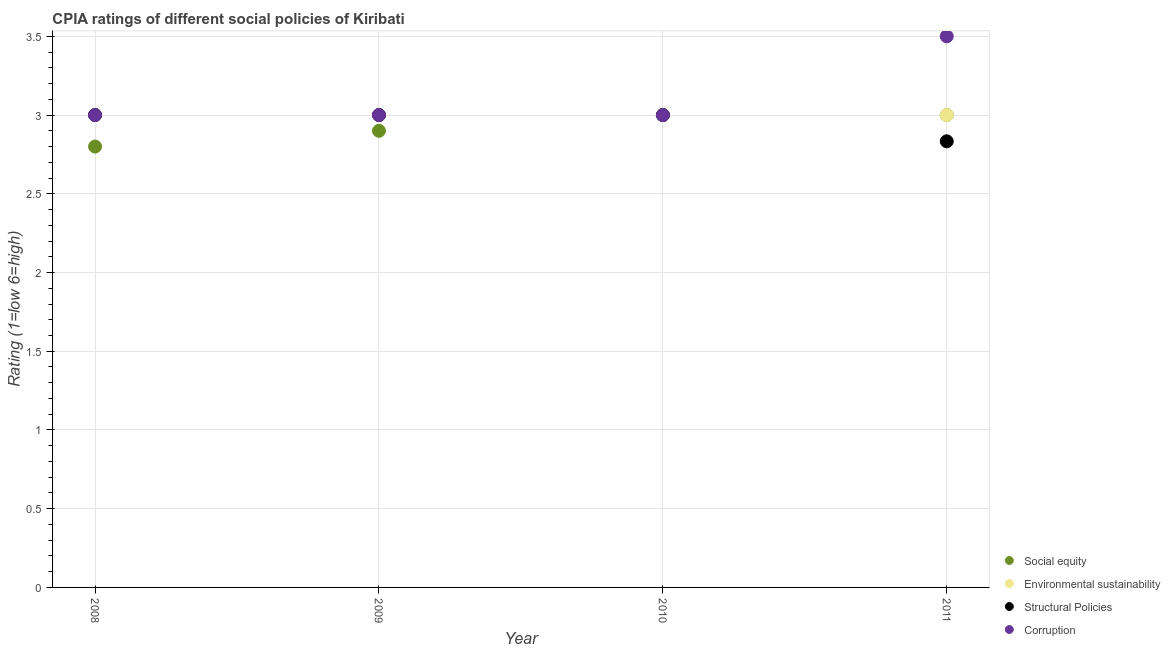Is the number of dotlines equal to the number of legend labels?
Ensure brevity in your answer.  Yes. What is the cpia rating of environmental sustainability in 2009?
Provide a short and direct response. 3. Across all years, what is the maximum cpia rating of corruption?
Your response must be concise. 3.5. Across all years, what is the minimum cpia rating of environmental sustainability?
Provide a succinct answer. 3. What is the total cpia rating of environmental sustainability in the graph?
Make the answer very short. 12. What is the difference between the cpia rating of structural policies in 2009 and the cpia rating of corruption in 2008?
Your answer should be compact. 0. What is the average cpia rating of structural policies per year?
Offer a very short reply. 2.96. Is the difference between the cpia rating of environmental sustainability in 2008 and 2011 greater than the difference between the cpia rating of social equity in 2008 and 2011?
Offer a very short reply. Yes. Is the sum of the cpia rating of corruption in 2008 and 2011 greater than the maximum cpia rating of environmental sustainability across all years?
Make the answer very short. Yes. Is it the case that in every year, the sum of the cpia rating of social equity and cpia rating of environmental sustainability is greater than the cpia rating of structural policies?
Offer a very short reply. Yes. Does the cpia rating of environmental sustainability monotonically increase over the years?
Keep it short and to the point. No. Is the cpia rating of social equity strictly less than the cpia rating of environmental sustainability over the years?
Provide a short and direct response. No. What is the difference between two consecutive major ticks on the Y-axis?
Your response must be concise. 0.5. Are the values on the major ticks of Y-axis written in scientific E-notation?
Offer a terse response. No. How many legend labels are there?
Your response must be concise. 4. What is the title of the graph?
Give a very brief answer. CPIA ratings of different social policies of Kiribati. Does "Others" appear as one of the legend labels in the graph?
Provide a short and direct response. No. What is the Rating (1=low 6=high) of Social equity in 2008?
Make the answer very short. 2.8. What is the Rating (1=low 6=high) of Environmental sustainability in 2009?
Give a very brief answer. 3. What is the Rating (1=low 6=high) in Structural Policies in 2011?
Provide a succinct answer. 2.83. What is the Rating (1=low 6=high) in Corruption in 2011?
Ensure brevity in your answer.  3.5. Across all years, what is the maximum Rating (1=low 6=high) of Social equity?
Ensure brevity in your answer.  3. Across all years, what is the maximum Rating (1=low 6=high) in Environmental sustainability?
Offer a very short reply. 3. Across all years, what is the maximum Rating (1=low 6=high) of Structural Policies?
Ensure brevity in your answer.  3. Across all years, what is the maximum Rating (1=low 6=high) of Corruption?
Give a very brief answer. 3.5. Across all years, what is the minimum Rating (1=low 6=high) of Structural Policies?
Ensure brevity in your answer.  2.83. Across all years, what is the minimum Rating (1=low 6=high) of Corruption?
Provide a short and direct response. 3. What is the total Rating (1=low 6=high) of Social equity in the graph?
Offer a terse response. 11.7. What is the total Rating (1=low 6=high) in Environmental sustainability in the graph?
Your response must be concise. 12. What is the total Rating (1=low 6=high) in Structural Policies in the graph?
Ensure brevity in your answer.  11.83. What is the total Rating (1=low 6=high) in Corruption in the graph?
Give a very brief answer. 12.5. What is the difference between the Rating (1=low 6=high) of Social equity in 2008 and that in 2009?
Provide a succinct answer. -0.1. What is the difference between the Rating (1=low 6=high) in Structural Policies in 2008 and that in 2009?
Provide a short and direct response. 0. What is the difference between the Rating (1=low 6=high) of Environmental sustainability in 2008 and that in 2010?
Give a very brief answer. 0. What is the difference between the Rating (1=low 6=high) in Social equity in 2008 and that in 2011?
Your answer should be compact. -0.2. What is the difference between the Rating (1=low 6=high) in Environmental sustainability in 2008 and that in 2011?
Provide a succinct answer. 0. What is the difference between the Rating (1=low 6=high) in Structural Policies in 2009 and that in 2010?
Offer a terse response. 0. What is the difference between the Rating (1=low 6=high) in Corruption in 2009 and that in 2010?
Provide a succinct answer. 0. What is the difference between the Rating (1=low 6=high) in Corruption in 2009 and that in 2011?
Provide a succinct answer. -0.5. What is the difference between the Rating (1=low 6=high) of Social equity in 2010 and that in 2011?
Your answer should be very brief. 0. What is the difference between the Rating (1=low 6=high) in Structural Policies in 2010 and that in 2011?
Offer a very short reply. 0.17. What is the difference between the Rating (1=low 6=high) in Corruption in 2010 and that in 2011?
Offer a very short reply. -0.5. What is the difference between the Rating (1=low 6=high) in Social equity in 2008 and the Rating (1=low 6=high) in Corruption in 2009?
Keep it short and to the point. -0.2. What is the difference between the Rating (1=low 6=high) of Environmental sustainability in 2008 and the Rating (1=low 6=high) of Structural Policies in 2009?
Ensure brevity in your answer.  0. What is the difference between the Rating (1=low 6=high) in Structural Policies in 2008 and the Rating (1=low 6=high) in Corruption in 2009?
Provide a succinct answer. 0. What is the difference between the Rating (1=low 6=high) in Social equity in 2008 and the Rating (1=low 6=high) in Environmental sustainability in 2010?
Provide a succinct answer. -0.2. What is the difference between the Rating (1=low 6=high) in Environmental sustainability in 2008 and the Rating (1=low 6=high) in Structural Policies in 2010?
Give a very brief answer. 0. What is the difference between the Rating (1=low 6=high) of Environmental sustainability in 2008 and the Rating (1=low 6=high) of Corruption in 2010?
Provide a succinct answer. 0. What is the difference between the Rating (1=low 6=high) in Structural Policies in 2008 and the Rating (1=low 6=high) in Corruption in 2010?
Keep it short and to the point. 0. What is the difference between the Rating (1=low 6=high) of Social equity in 2008 and the Rating (1=low 6=high) of Environmental sustainability in 2011?
Give a very brief answer. -0.2. What is the difference between the Rating (1=low 6=high) in Social equity in 2008 and the Rating (1=low 6=high) in Structural Policies in 2011?
Keep it short and to the point. -0.03. What is the difference between the Rating (1=low 6=high) of Social equity in 2008 and the Rating (1=low 6=high) of Corruption in 2011?
Offer a terse response. -0.7. What is the difference between the Rating (1=low 6=high) of Environmental sustainability in 2008 and the Rating (1=low 6=high) of Structural Policies in 2011?
Give a very brief answer. 0.17. What is the difference between the Rating (1=low 6=high) in Structural Policies in 2008 and the Rating (1=low 6=high) in Corruption in 2011?
Keep it short and to the point. -0.5. What is the difference between the Rating (1=low 6=high) in Social equity in 2009 and the Rating (1=low 6=high) in Environmental sustainability in 2010?
Ensure brevity in your answer.  -0.1. What is the difference between the Rating (1=low 6=high) in Environmental sustainability in 2009 and the Rating (1=low 6=high) in Structural Policies in 2010?
Keep it short and to the point. 0. What is the difference between the Rating (1=low 6=high) of Environmental sustainability in 2009 and the Rating (1=low 6=high) of Corruption in 2010?
Offer a terse response. 0. What is the difference between the Rating (1=low 6=high) in Social equity in 2009 and the Rating (1=low 6=high) in Environmental sustainability in 2011?
Keep it short and to the point. -0.1. What is the difference between the Rating (1=low 6=high) of Social equity in 2009 and the Rating (1=low 6=high) of Structural Policies in 2011?
Give a very brief answer. 0.07. What is the difference between the Rating (1=low 6=high) of Environmental sustainability in 2009 and the Rating (1=low 6=high) of Corruption in 2011?
Offer a very short reply. -0.5. What is the difference between the Rating (1=low 6=high) of Social equity in 2010 and the Rating (1=low 6=high) of Environmental sustainability in 2011?
Your answer should be compact. 0. What is the average Rating (1=low 6=high) of Social equity per year?
Make the answer very short. 2.92. What is the average Rating (1=low 6=high) in Environmental sustainability per year?
Your answer should be very brief. 3. What is the average Rating (1=low 6=high) of Structural Policies per year?
Ensure brevity in your answer.  2.96. What is the average Rating (1=low 6=high) of Corruption per year?
Make the answer very short. 3.12. In the year 2008, what is the difference between the Rating (1=low 6=high) of Social equity and Rating (1=low 6=high) of Environmental sustainability?
Ensure brevity in your answer.  -0.2. In the year 2008, what is the difference between the Rating (1=low 6=high) in Social equity and Rating (1=low 6=high) in Structural Policies?
Offer a very short reply. -0.2. In the year 2008, what is the difference between the Rating (1=low 6=high) in Social equity and Rating (1=low 6=high) in Corruption?
Make the answer very short. -0.2. In the year 2008, what is the difference between the Rating (1=low 6=high) in Structural Policies and Rating (1=low 6=high) in Corruption?
Offer a terse response. 0. In the year 2009, what is the difference between the Rating (1=low 6=high) in Social equity and Rating (1=low 6=high) in Structural Policies?
Your answer should be very brief. -0.1. In the year 2009, what is the difference between the Rating (1=low 6=high) of Environmental sustainability and Rating (1=low 6=high) of Structural Policies?
Provide a succinct answer. 0. In the year 2009, what is the difference between the Rating (1=low 6=high) of Environmental sustainability and Rating (1=low 6=high) of Corruption?
Keep it short and to the point. 0. In the year 2010, what is the difference between the Rating (1=low 6=high) of Environmental sustainability and Rating (1=low 6=high) of Structural Policies?
Ensure brevity in your answer.  0. In the year 2011, what is the difference between the Rating (1=low 6=high) in Social equity and Rating (1=low 6=high) in Environmental sustainability?
Make the answer very short. 0. In the year 2011, what is the difference between the Rating (1=low 6=high) in Social equity and Rating (1=low 6=high) in Structural Policies?
Your answer should be very brief. 0.17. In the year 2011, what is the difference between the Rating (1=low 6=high) of Social equity and Rating (1=low 6=high) of Corruption?
Provide a short and direct response. -0.5. In the year 2011, what is the difference between the Rating (1=low 6=high) in Environmental sustainability and Rating (1=low 6=high) in Structural Policies?
Provide a short and direct response. 0.17. In the year 2011, what is the difference between the Rating (1=low 6=high) in Environmental sustainability and Rating (1=low 6=high) in Corruption?
Ensure brevity in your answer.  -0.5. In the year 2011, what is the difference between the Rating (1=low 6=high) of Structural Policies and Rating (1=low 6=high) of Corruption?
Your answer should be very brief. -0.67. What is the ratio of the Rating (1=low 6=high) of Social equity in 2008 to that in 2009?
Your response must be concise. 0.97. What is the ratio of the Rating (1=low 6=high) in Environmental sustainability in 2008 to that in 2009?
Your answer should be compact. 1. What is the ratio of the Rating (1=low 6=high) of Structural Policies in 2008 to that in 2009?
Ensure brevity in your answer.  1. What is the ratio of the Rating (1=low 6=high) of Structural Policies in 2008 to that in 2010?
Provide a short and direct response. 1. What is the ratio of the Rating (1=low 6=high) in Corruption in 2008 to that in 2010?
Make the answer very short. 1. What is the ratio of the Rating (1=low 6=high) of Environmental sustainability in 2008 to that in 2011?
Keep it short and to the point. 1. What is the ratio of the Rating (1=low 6=high) of Structural Policies in 2008 to that in 2011?
Provide a succinct answer. 1.06. What is the ratio of the Rating (1=low 6=high) of Corruption in 2008 to that in 2011?
Your answer should be very brief. 0.86. What is the ratio of the Rating (1=low 6=high) in Social equity in 2009 to that in 2010?
Provide a succinct answer. 0.97. What is the ratio of the Rating (1=low 6=high) of Environmental sustainability in 2009 to that in 2010?
Keep it short and to the point. 1. What is the ratio of the Rating (1=low 6=high) of Social equity in 2009 to that in 2011?
Your answer should be compact. 0.97. What is the ratio of the Rating (1=low 6=high) of Environmental sustainability in 2009 to that in 2011?
Offer a very short reply. 1. What is the ratio of the Rating (1=low 6=high) of Structural Policies in 2009 to that in 2011?
Make the answer very short. 1.06. What is the ratio of the Rating (1=low 6=high) in Corruption in 2009 to that in 2011?
Give a very brief answer. 0.86. What is the ratio of the Rating (1=low 6=high) of Environmental sustainability in 2010 to that in 2011?
Offer a very short reply. 1. What is the ratio of the Rating (1=low 6=high) of Structural Policies in 2010 to that in 2011?
Make the answer very short. 1.06. What is the difference between the highest and the second highest Rating (1=low 6=high) in Environmental sustainability?
Your answer should be very brief. 0. What is the difference between the highest and the second highest Rating (1=low 6=high) in Corruption?
Offer a very short reply. 0.5. What is the difference between the highest and the lowest Rating (1=low 6=high) in Environmental sustainability?
Make the answer very short. 0. What is the difference between the highest and the lowest Rating (1=low 6=high) in Corruption?
Ensure brevity in your answer.  0.5. 